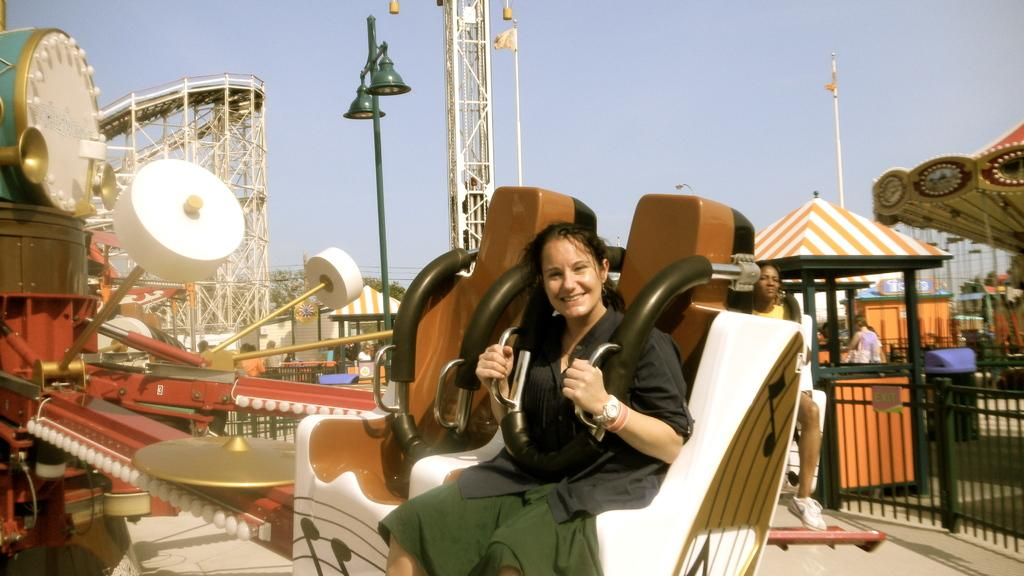Who is the main subject in the image? There is a girl in the image. What is the girl doing in the image? The girl is sitting on a ride. How does the girl feel in the image? The girl has a smile on her face, indicating that she is happy. What is the girl looking at in the image? The girl is looking at the camera. What can be seen behind the girl in the image? There is a rollercoaster behind the girl. What else can be seen in the background of the image? There are other rides visible in the background. What type of education is the girl pursuing in the image? There is no indication of the girl pursuing any education in the image; it shows her on a ride at an amusement park. 